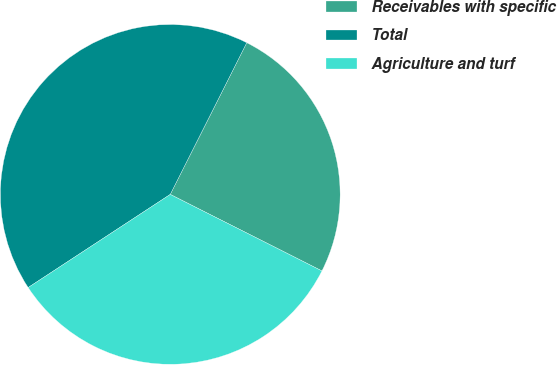Convert chart to OTSL. <chart><loc_0><loc_0><loc_500><loc_500><pie_chart><fcel>Receivables with specific<fcel>Total<fcel>Agriculture and turf<nl><fcel>25.0%<fcel>41.67%<fcel>33.33%<nl></chart> 